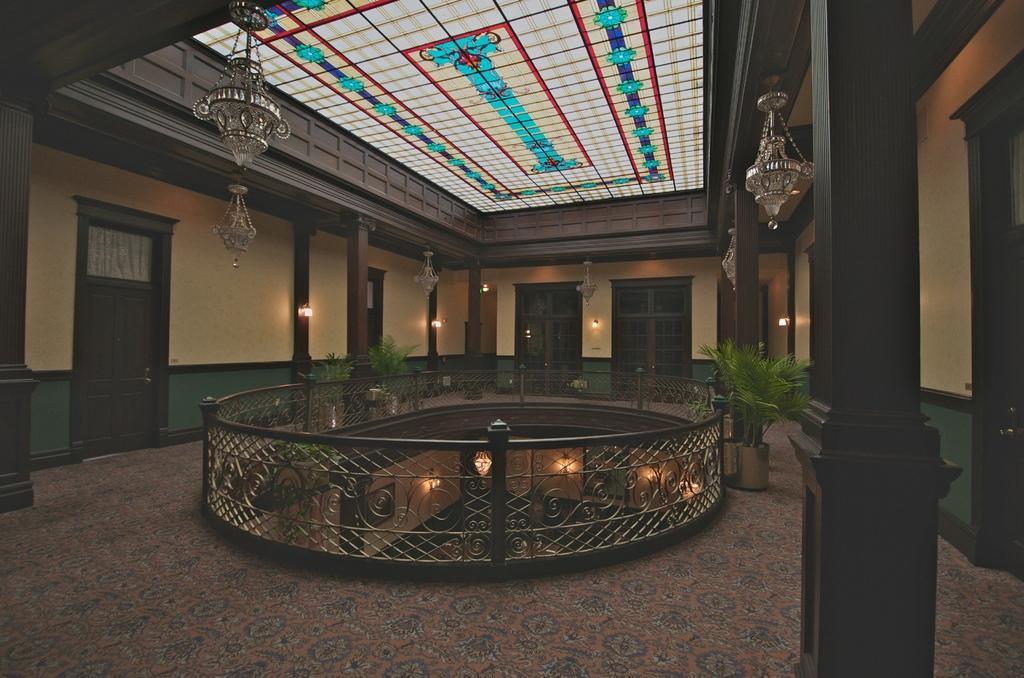Could you give a brief overview of what you see in this image? This is a picture of a building, In this image we can see some pillars, lights, doors, windows, potted plants, grille and the wall. 